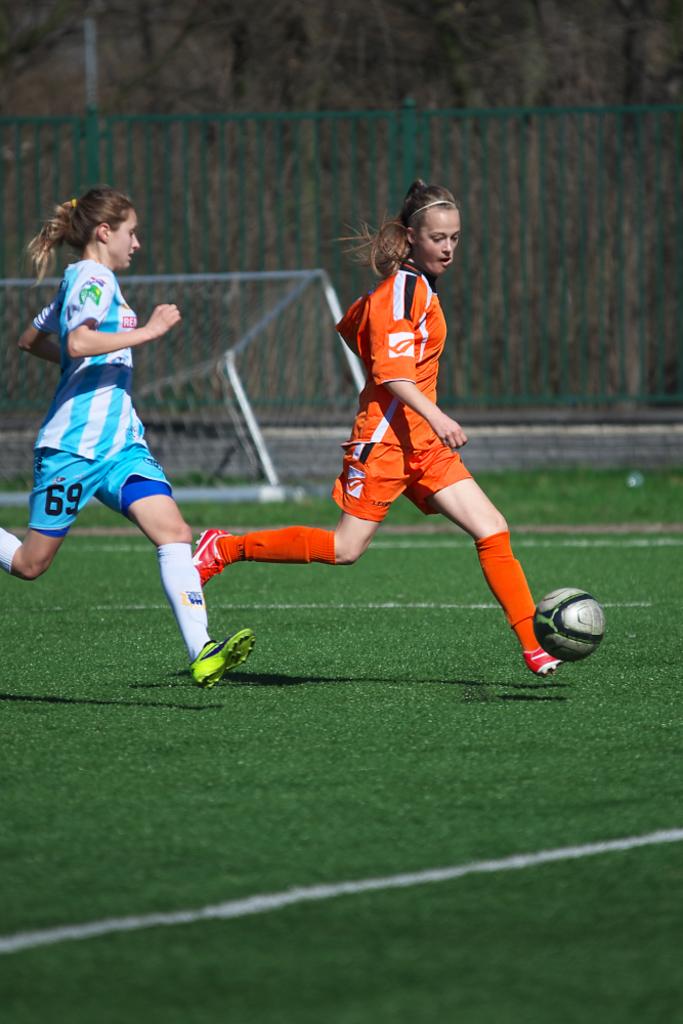What number is the blue player?
Ensure brevity in your answer.  69. 